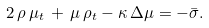<formula> <loc_0><loc_0><loc_500><loc_500>2 \, \rho \, \mu _ { t } \, + \, \mu \, \rho _ { t } - \kappa \, \Delta \mu = - \bar { \sigma } .</formula> 